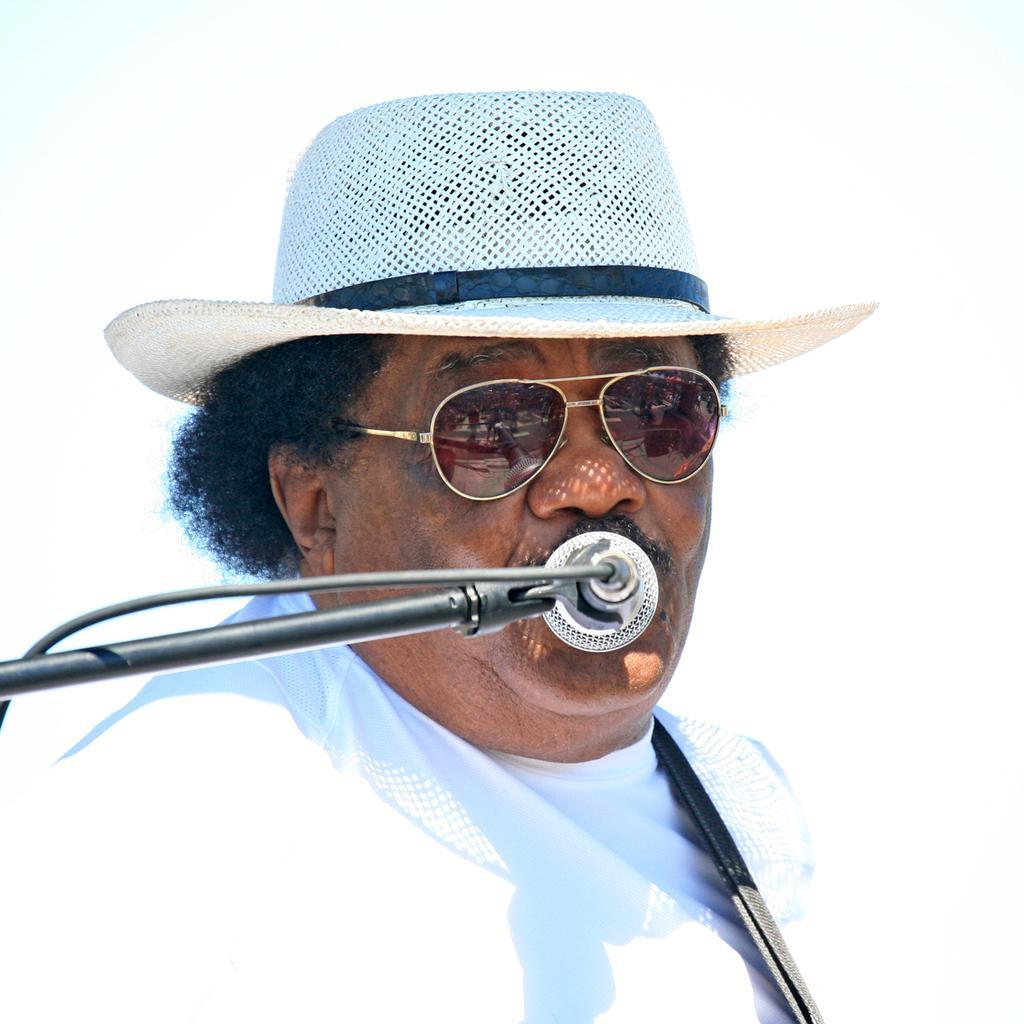How would you summarize this image in a sentence or two? In the center of the picture there is a person wearing a white dress, he is wearing a hat and spectacles. In the middle there is a mic. 